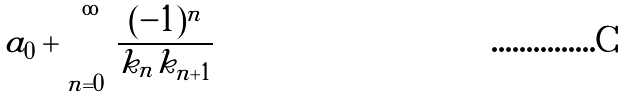<formula> <loc_0><loc_0><loc_500><loc_500>a _ { 0 } + \sum _ { n = 0 } ^ { \infty } \frac { ( - 1 ) ^ { n } } { k _ { n } k _ { n + 1 } }</formula> 